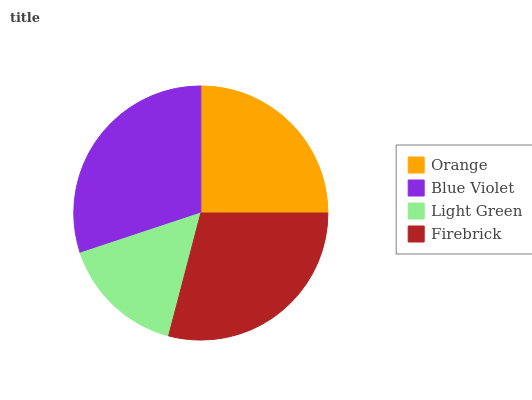Is Light Green the minimum?
Answer yes or no. Yes. Is Blue Violet the maximum?
Answer yes or no. Yes. Is Blue Violet the minimum?
Answer yes or no. No. Is Light Green the maximum?
Answer yes or no. No. Is Blue Violet greater than Light Green?
Answer yes or no. Yes. Is Light Green less than Blue Violet?
Answer yes or no. Yes. Is Light Green greater than Blue Violet?
Answer yes or no. No. Is Blue Violet less than Light Green?
Answer yes or no. No. Is Firebrick the high median?
Answer yes or no. Yes. Is Orange the low median?
Answer yes or no. Yes. Is Orange the high median?
Answer yes or no. No. Is Blue Violet the low median?
Answer yes or no. No. 